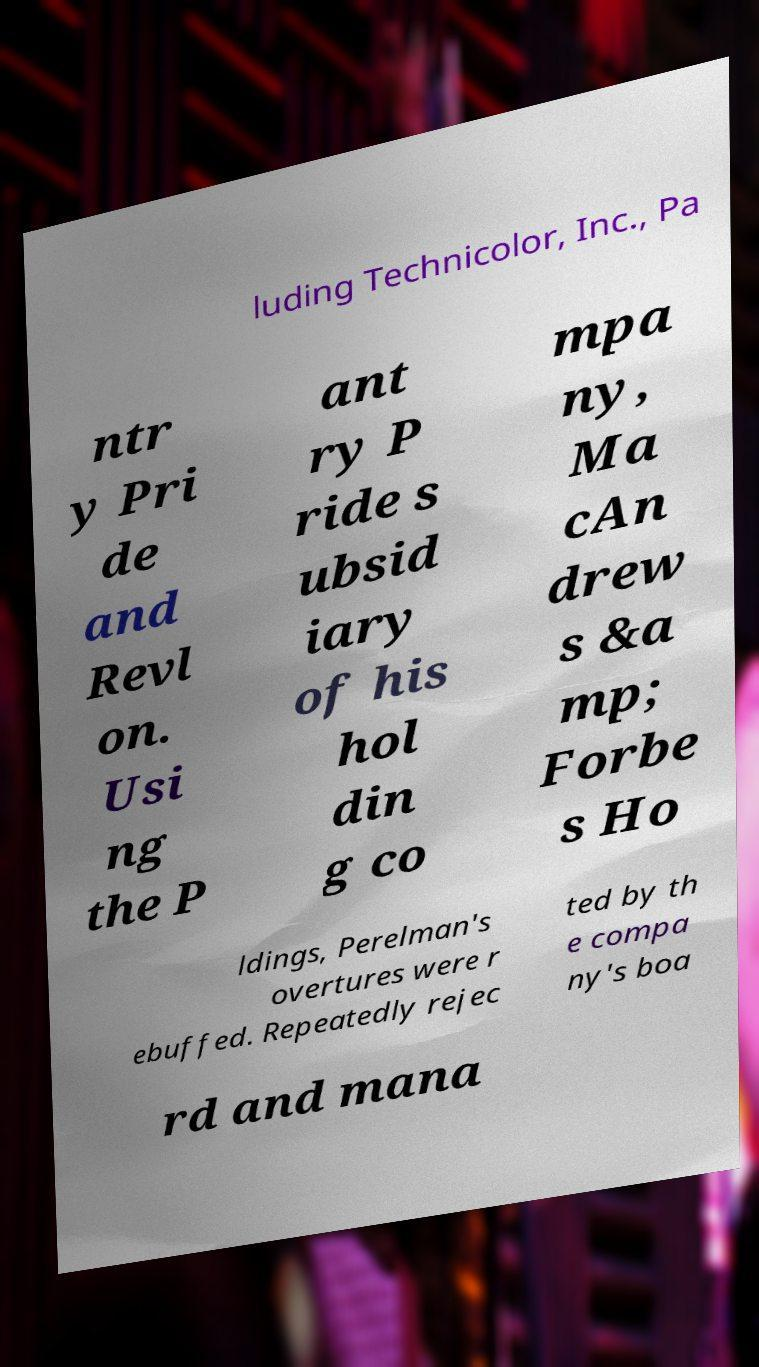What messages or text are displayed in this image? I need them in a readable, typed format. luding Technicolor, Inc., Pa ntr y Pri de and Revl on. Usi ng the P ant ry P ride s ubsid iary of his hol din g co mpa ny, Ma cAn drew s &a mp; Forbe s Ho ldings, Perelman's overtures were r ebuffed. Repeatedly rejec ted by th e compa ny's boa rd and mana 